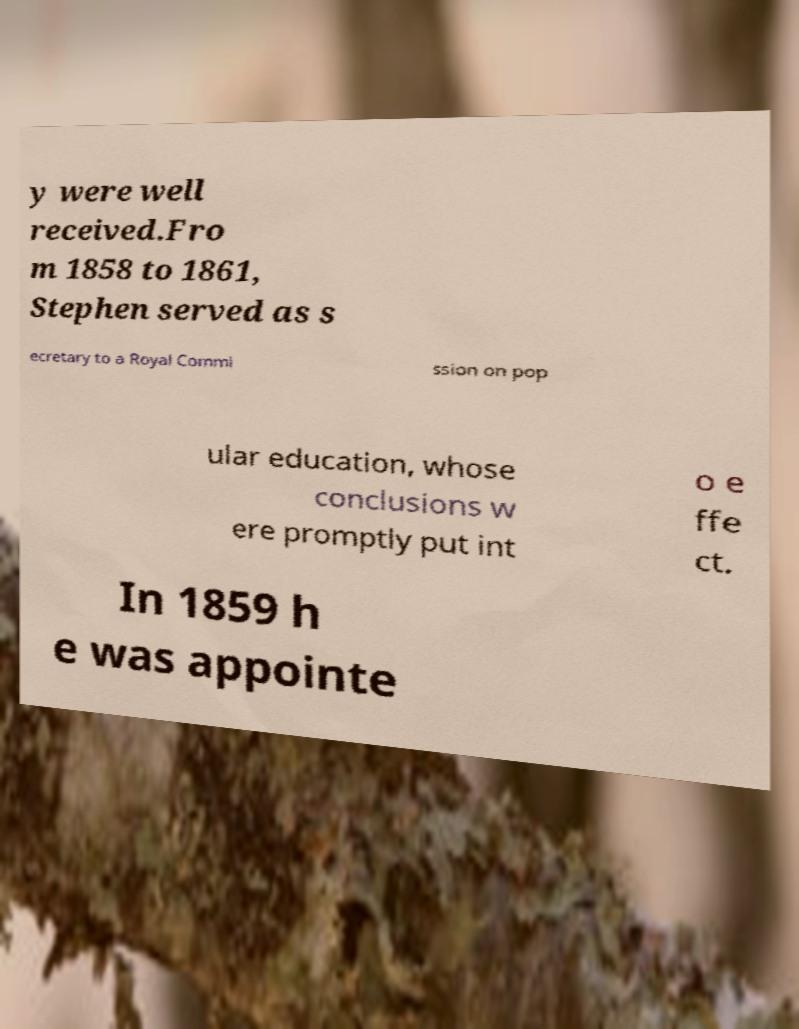Please read and relay the text visible in this image. What does it say? y were well received.Fro m 1858 to 1861, Stephen served as s ecretary to a Royal Commi ssion on pop ular education, whose conclusions w ere promptly put int o e ffe ct. In 1859 h e was appointe 